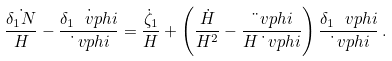<formula> <loc_0><loc_0><loc_500><loc_500>\frac { \dot { \delta _ { 1 } N } } { H } - \frac { \dot { \delta _ { 1 } \ v p h i } } { \dot { \ } v p h i } = \frac { \dot { \zeta } _ { 1 } } { H } + \left ( \frac { \dot { H } } { H ^ { 2 } } - \frac { \ddot { \ } v p h i } { H \dot { \ } v p h i } \right ) \frac { \delta _ { 1 } \ v p h i } { \dot { \ } v p h i } \, .</formula> 